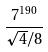Convert formula to latex. <formula><loc_0><loc_0><loc_500><loc_500>\frac { 7 ^ { 1 9 0 } } { \sqrt { 4 } / 8 }</formula> 